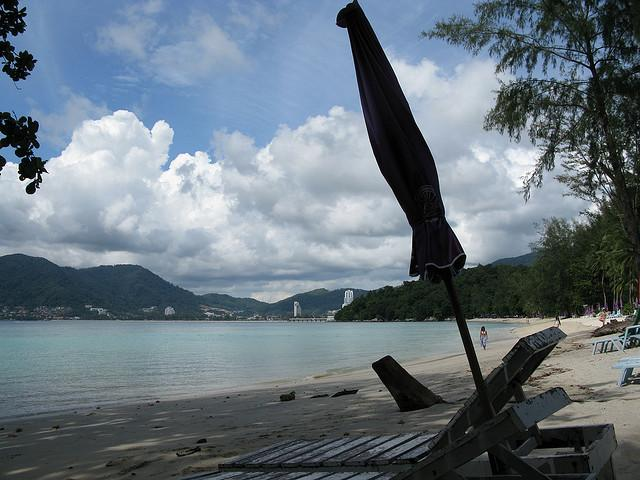What might this umbrella normally be used for? shade 